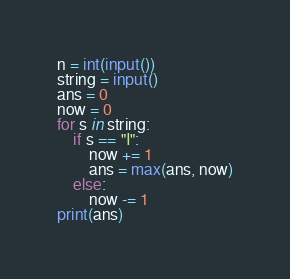Convert code to text. <code><loc_0><loc_0><loc_500><loc_500><_Python_>n = int(input())
string = input()
ans = 0
now = 0
for s in string:
    if s == "I":
        now += 1
        ans = max(ans, now)
    else:
        now -= 1
print(ans)
</code> 